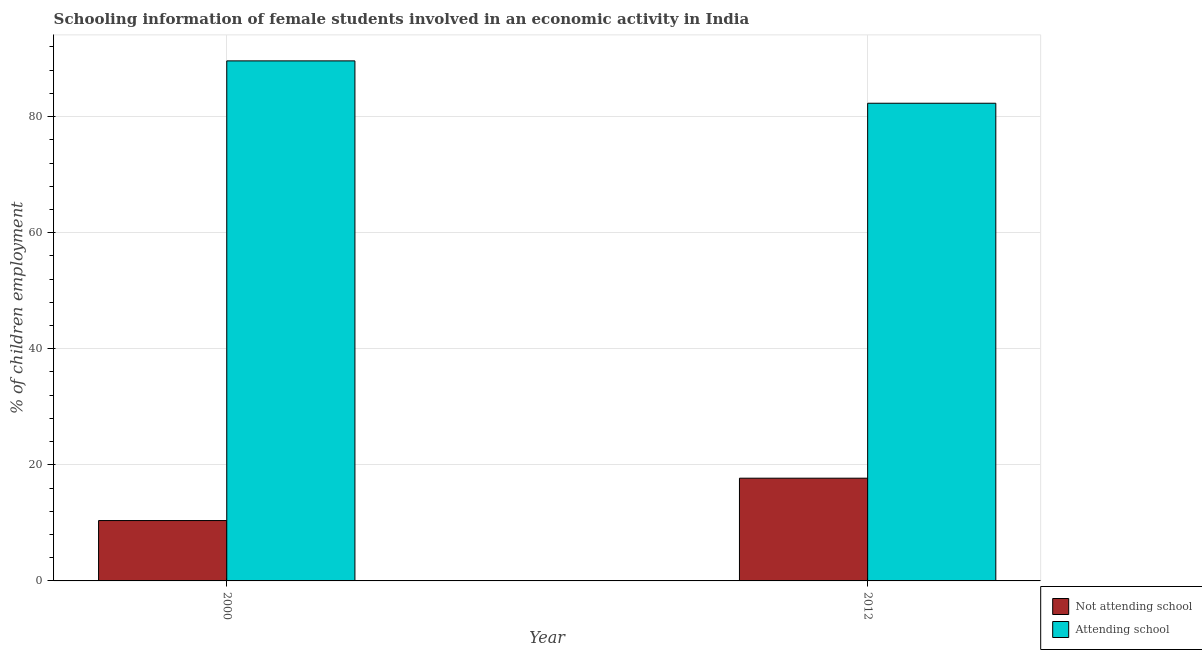How many different coloured bars are there?
Provide a succinct answer. 2. How many groups of bars are there?
Ensure brevity in your answer.  2. Are the number of bars per tick equal to the number of legend labels?
Ensure brevity in your answer.  Yes. How many bars are there on the 2nd tick from the right?
Ensure brevity in your answer.  2. What is the percentage of employed females who are attending school in 2000?
Offer a very short reply. 89.6. Across all years, what is the maximum percentage of employed females who are not attending school?
Your answer should be very brief. 17.7. Across all years, what is the minimum percentage of employed females who are not attending school?
Give a very brief answer. 10.4. In which year was the percentage of employed females who are not attending school maximum?
Make the answer very short. 2012. In which year was the percentage of employed females who are not attending school minimum?
Your answer should be very brief. 2000. What is the total percentage of employed females who are not attending school in the graph?
Offer a very short reply. 28.1. What is the difference between the percentage of employed females who are not attending school in 2000 and that in 2012?
Provide a succinct answer. -7.3. What is the difference between the percentage of employed females who are attending school in 2012 and the percentage of employed females who are not attending school in 2000?
Your answer should be very brief. -7.3. What is the average percentage of employed females who are not attending school per year?
Provide a succinct answer. 14.05. What is the ratio of the percentage of employed females who are attending school in 2000 to that in 2012?
Provide a short and direct response. 1.09. Is the percentage of employed females who are not attending school in 2000 less than that in 2012?
Your answer should be very brief. Yes. What does the 2nd bar from the left in 2012 represents?
Your answer should be very brief. Attending school. What does the 1st bar from the right in 2012 represents?
Provide a short and direct response. Attending school. How many bars are there?
Offer a very short reply. 4. How many years are there in the graph?
Keep it short and to the point. 2. What is the difference between two consecutive major ticks on the Y-axis?
Offer a very short reply. 20. Does the graph contain any zero values?
Offer a very short reply. No. Does the graph contain grids?
Offer a very short reply. Yes. Where does the legend appear in the graph?
Offer a very short reply. Bottom right. What is the title of the graph?
Your response must be concise. Schooling information of female students involved in an economic activity in India. What is the label or title of the Y-axis?
Provide a succinct answer. % of children employment. What is the % of children employment in Not attending school in 2000?
Make the answer very short. 10.4. What is the % of children employment in Attending school in 2000?
Your response must be concise. 89.6. What is the % of children employment of Attending school in 2012?
Provide a succinct answer. 82.3. Across all years, what is the maximum % of children employment of Not attending school?
Your answer should be very brief. 17.7. Across all years, what is the maximum % of children employment of Attending school?
Offer a terse response. 89.6. Across all years, what is the minimum % of children employment in Not attending school?
Your response must be concise. 10.4. Across all years, what is the minimum % of children employment of Attending school?
Your answer should be compact. 82.3. What is the total % of children employment of Not attending school in the graph?
Provide a short and direct response. 28.1. What is the total % of children employment in Attending school in the graph?
Offer a very short reply. 171.9. What is the difference between the % of children employment of Not attending school in 2000 and that in 2012?
Ensure brevity in your answer.  -7.3. What is the difference between the % of children employment in Not attending school in 2000 and the % of children employment in Attending school in 2012?
Offer a very short reply. -71.9. What is the average % of children employment of Not attending school per year?
Make the answer very short. 14.05. What is the average % of children employment of Attending school per year?
Offer a terse response. 85.95. In the year 2000, what is the difference between the % of children employment of Not attending school and % of children employment of Attending school?
Give a very brief answer. -79.2. In the year 2012, what is the difference between the % of children employment in Not attending school and % of children employment in Attending school?
Offer a terse response. -64.6. What is the ratio of the % of children employment of Not attending school in 2000 to that in 2012?
Offer a very short reply. 0.59. What is the ratio of the % of children employment in Attending school in 2000 to that in 2012?
Offer a terse response. 1.09. What is the difference between the highest and the second highest % of children employment of Not attending school?
Offer a terse response. 7.3. What is the difference between the highest and the second highest % of children employment of Attending school?
Your answer should be compact. 7.3. What is the difference between the highest and the lowest % of children employment in Attending school?
Your response must be concise. 7.3. 